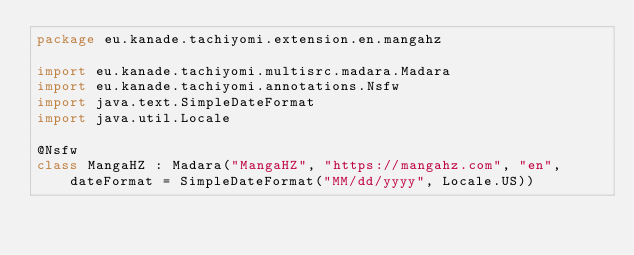Convert code to text. <code><loc_0><loc_0><loc_500><loc_500><_Kotlin_>package eu.kanade.tachiyomi.extension.en.mangahz

import eu.kanade.tachiyomi.multisrc.madara.Madara
import eu.kanade.tachiyomi.annotations.Nsfw
import java.text.SimpleDateFormat
import java.util.Locale

@Nsfw
class MangaHZ : Madara("MangaHZ", "https://mangahz.com", "en", dateFormat = SimpleDateFormat("MM/dd/yyyy", Locale.US))
</code> 